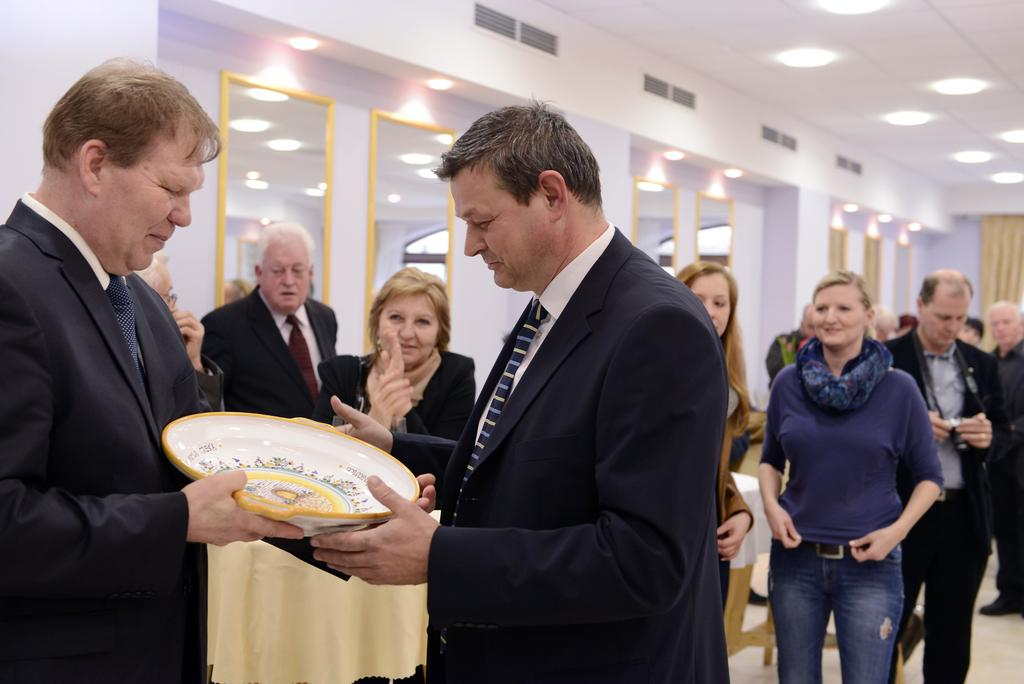How many people are in the image? There are two people in the image. What are the two people wearing? The two people are wearing suits. What are the two people holding in the image? The two people are holding a bowl-like thing. Can you describe the background of the image? There are other people visible in the background, as well as mirrors. What is on the roof in the image? There are lights on the roof. What type of dinner is being served in the library in the image? There is no library or dinner present in the image. What is the cause of the burn on the person's hand in the image? There is no burn or indication of any injury on anyone's hand in the image. 